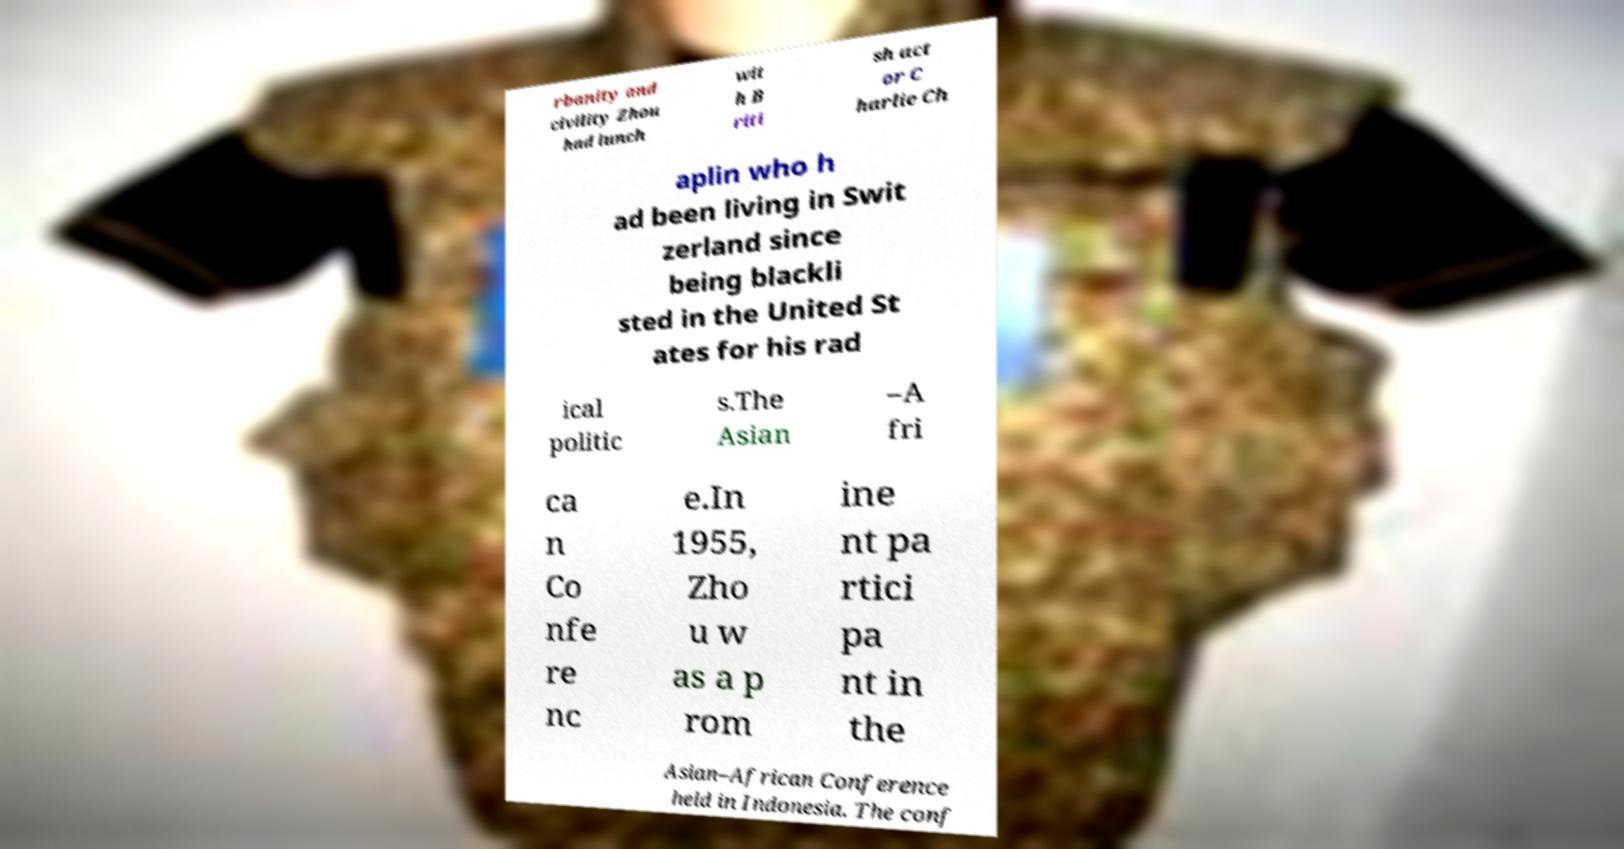Could you assist in decoding the text presented in this image and type it out clearly? rbanity and civility Zhou had lunch wit h B riti sh act or C harlie Ch aplin who h ad been living in Swit zerland since being blackli sted in the United St ates for his rad ical politic s.The Asian –A fri ca n Co nfe re nc e.In 1955, Zho u w as a p rom ine nt pa rtici pa nt in the Asian–African Conference held in Indonesia. The conf 